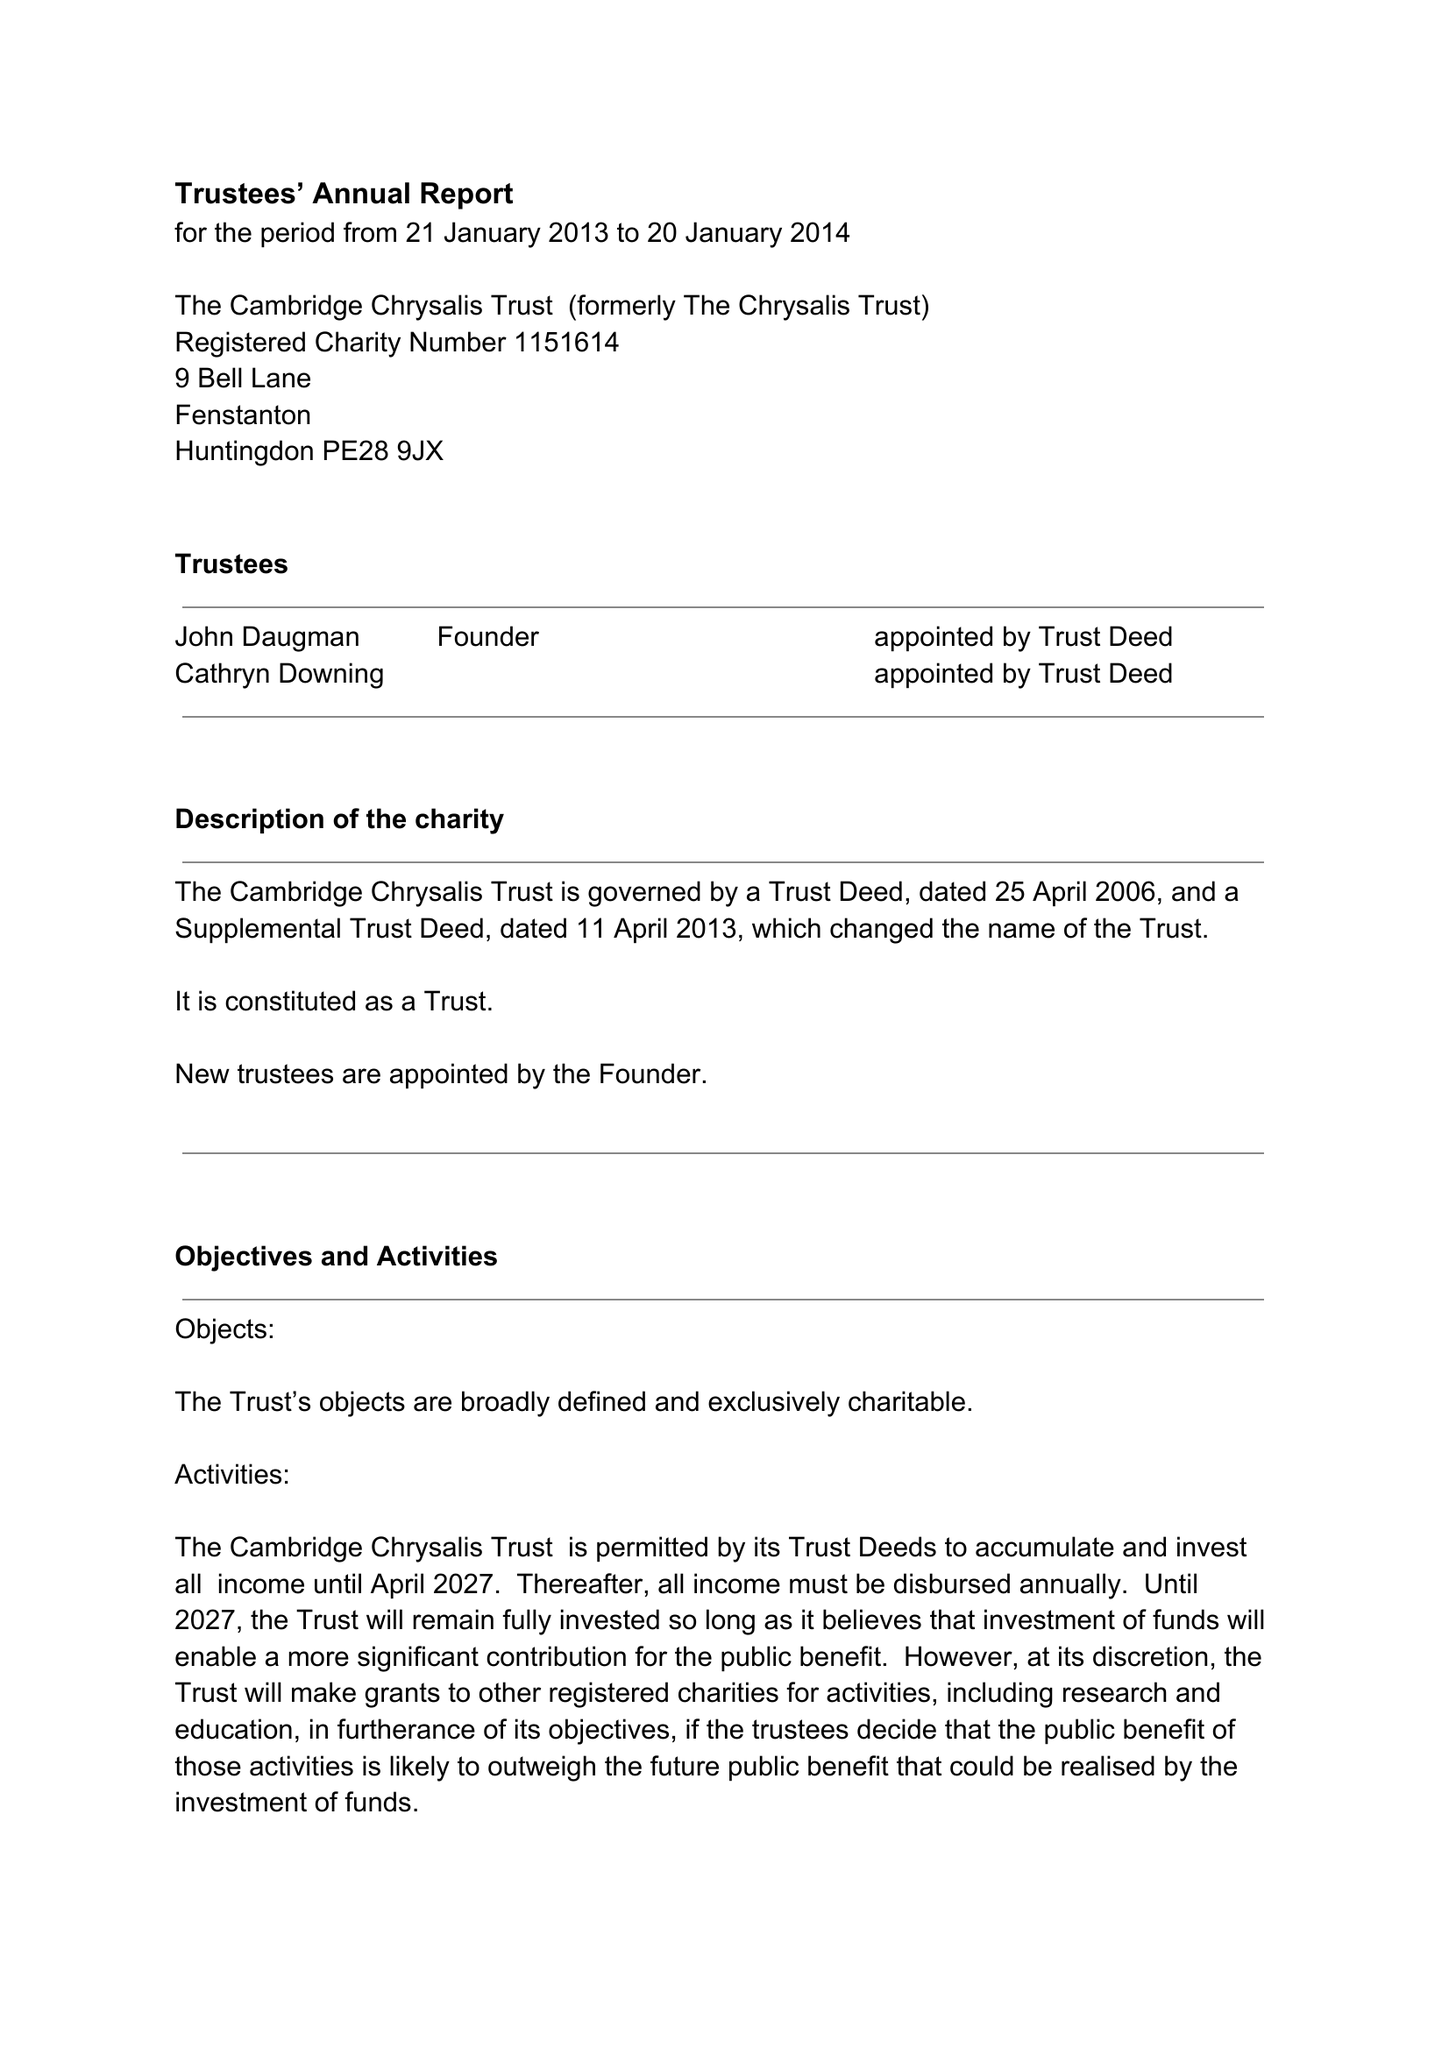What is the value for the address__street_line?
Answer the question using a single word or phrase. 9 BELL LANE 